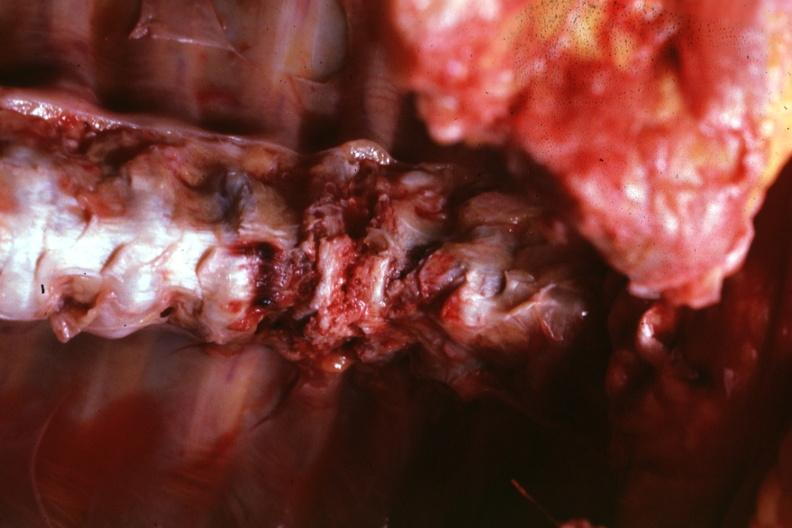does this image show in situ close-up well shown?
Answer the question using a single word or phrase. Yes 